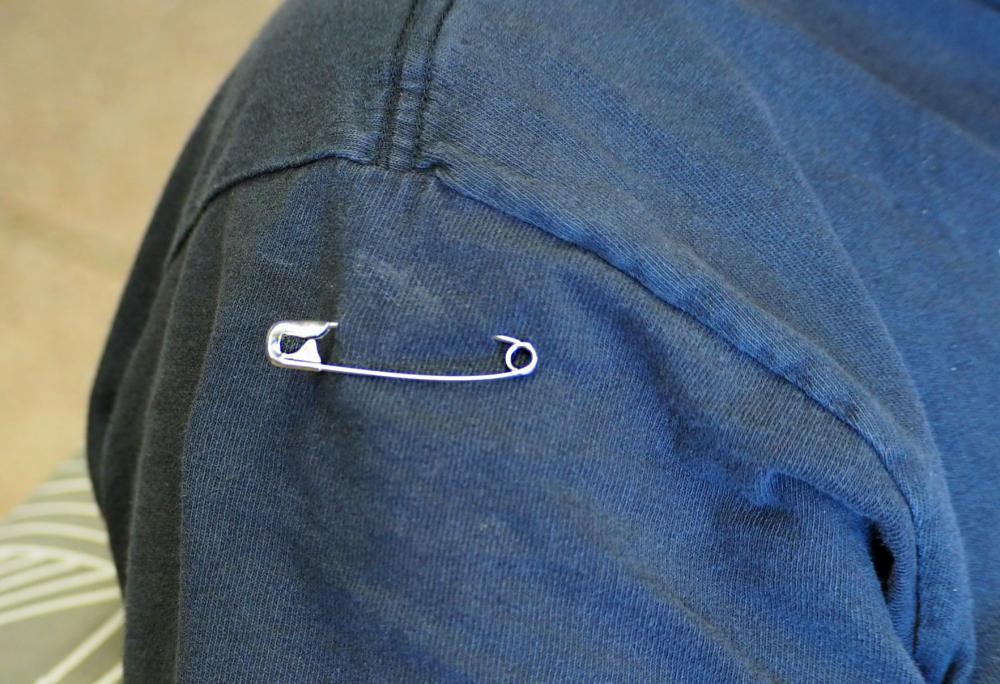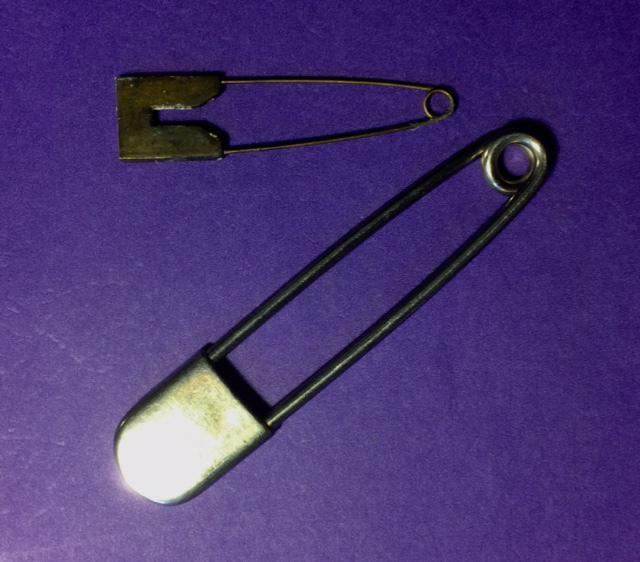The first image is the image on the left, the second image is the image on the right. For the images shown, is this caption "The left image shows a single safety pin pinned on a blue cloth." true? Answer yes or no. Yes. The first image is the image on the left, the second image is the image on the right. Evaluate the accuracy of this statement regarding the images: "An image shows a necklace designed to include at least one safety pin.". Is it true? Answer yes or no. No. 